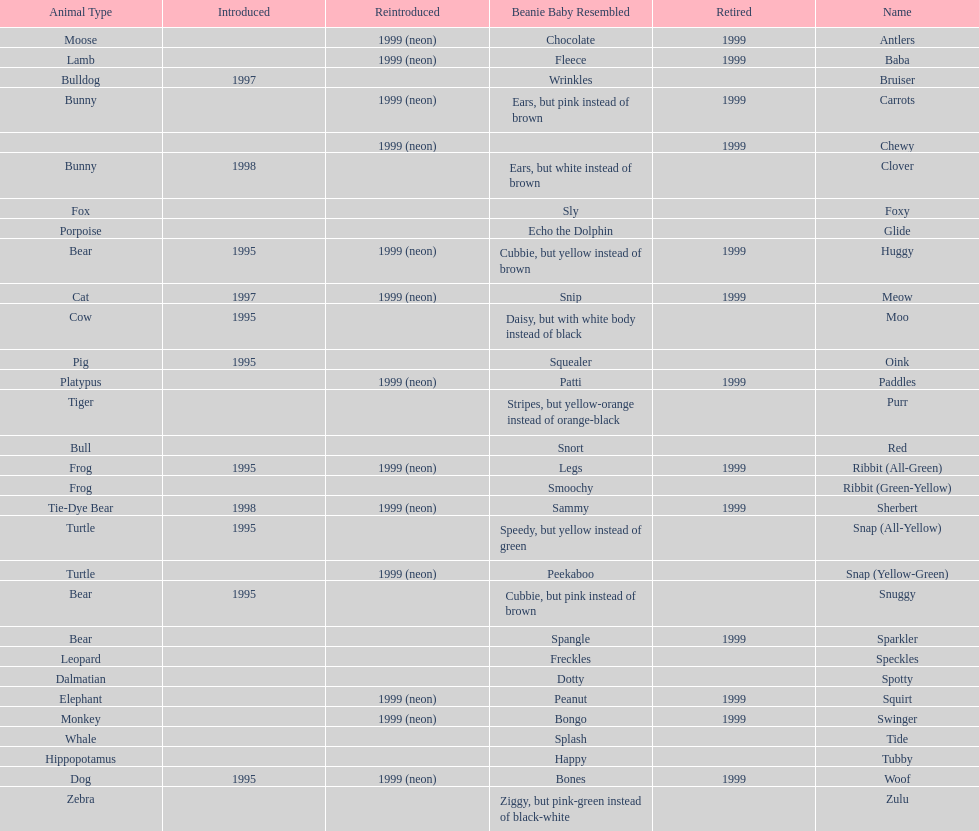What is the total number of pillow pals that were reintroduced as a neon variety? 13. 